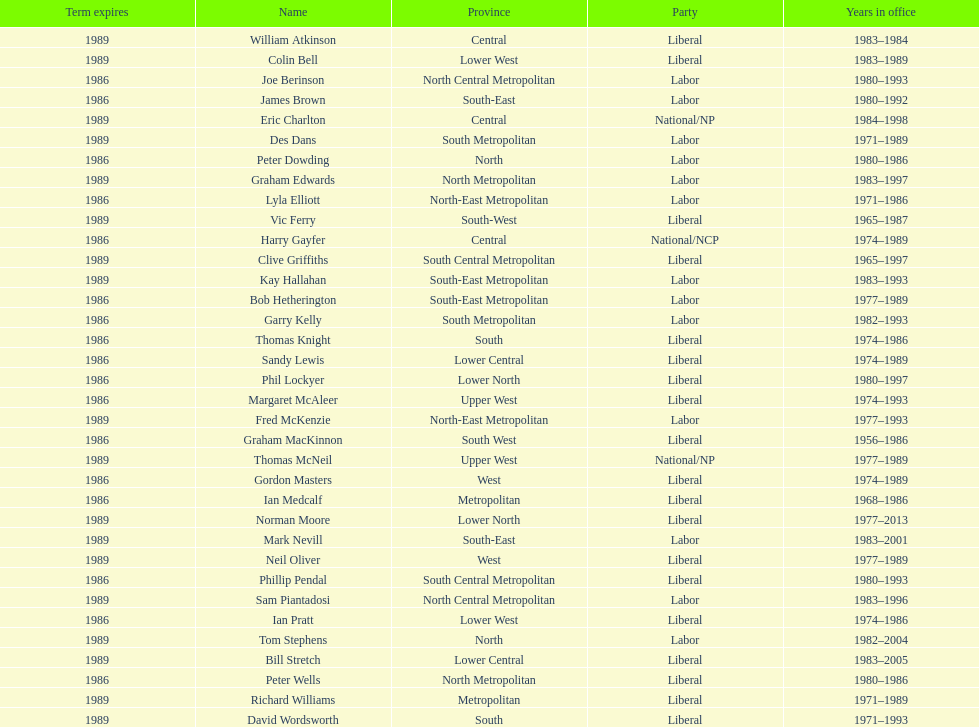How many members were party of lower west province? 2. 